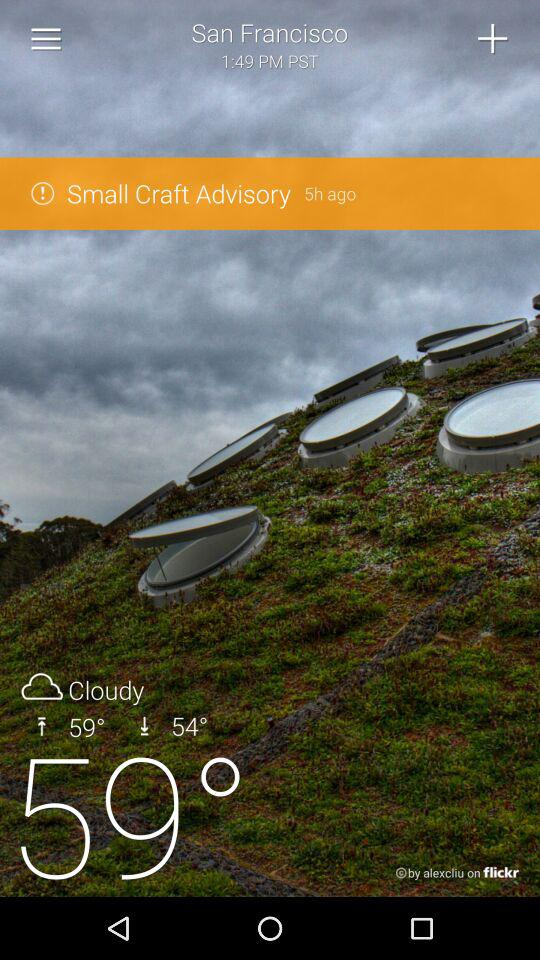How many more degrees Fahrenheit is the high temperature than the low temperature?
Answer the question using a single word or phrase. 5 